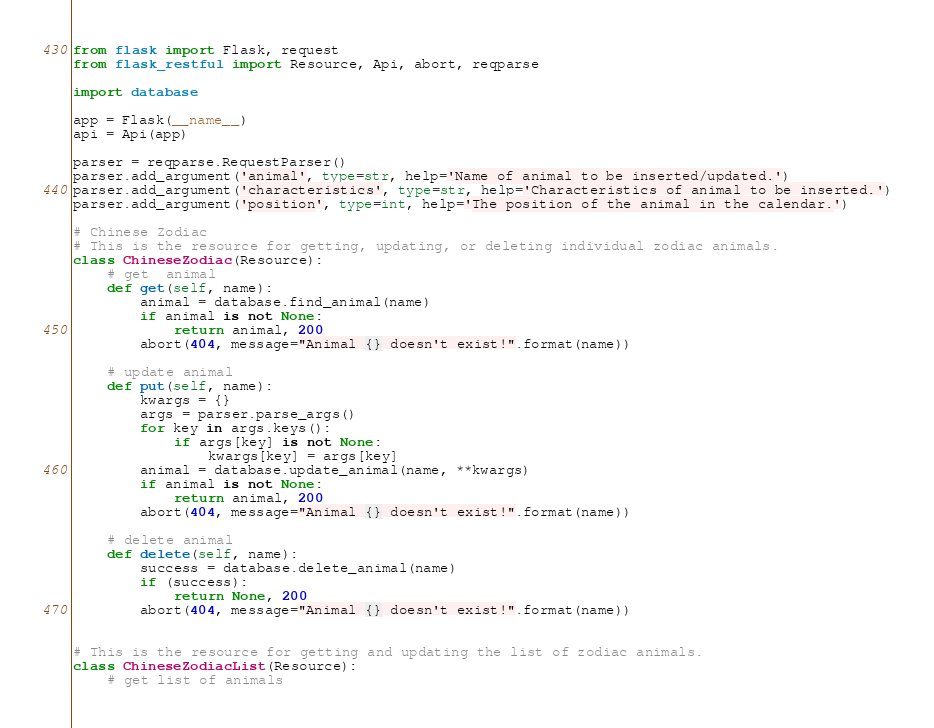Convert code to text. <code><loc_0><loc_0><loc_500><loc_500><_Python_>from flask import Flask, request
from flask_restful import Resource, Api, abort, reqparse

import database

app = Flask(__name__)
api = Api(app)

parser = reqparse.RequestParser()
parser.add_argument('animal', type=str, help='Name of animal to be inserted/updated.')
parser.add_argument('characteristics', type=str, help='Characteristics of animal to be inserted.')
parser.add_argument('position', type=int, help='The position of the animal in the calendar.')

# Chinese Zodiac
# This is the resource for getting, updating, or deleting individual zodiac animals.
class ChineseZodiac(Resource):
    # get  animal
    def get(self, name):
        animal = database.find_animal(name)
        if animal is not None:
            return animal, 200
        abort(404, message="Animal {} doesn't exist!".format(name))

    # update animal
    def put(self, name):
        kwargs = {}
        args = parser.parse_args()
        for key in args.keys():
            if args[key] is not None:
                kwargs[key] = args[key]
        animal = database.update_animal(name, **kwargs)
        if animal is not None:
            return animal, 200
        abort(404, message="Animal {} doesn't exist!".format(name))

    # delete animal
    def delete(self, name):
        success = database.delete_animal(name)
        if (success):
            return None, 200
        abort(404, message="Animal {} doesn't exist!".format(name))


# This is the resource for getting and updating the list of zodiac animals.
class ChineseZodiacList(Resource):
    # get list of animals</code> 